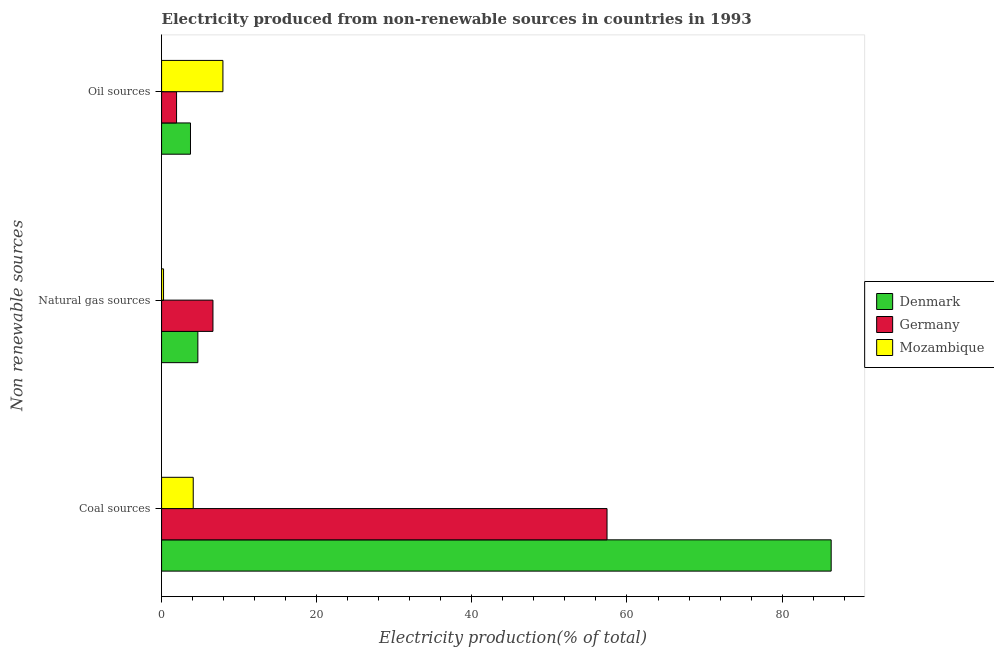How many bars are there on the 3rd tick from the bottom?
Make the answer very short. 3. What is the label of the 2nd group of bars from the top?
Give a very brief answer. Natural gas sources. What is the percentage of electricity produced by natural gas in Germany?
Provide a short and direct response. 6.62. Across all countries, what is the maximum percentage of electricity produced by coal?
Your answer should be compact. 86.32. Across all countries, what is the minimum percentage of electricity produced by coal?
Make the answer very short. 4.08. In which country was the percentage of electricity produced by oil sources maximum?
Your answer should be compact. Mozambique. In which country was the percentage of electricity produced by natural gas minimum?
Offer a terse response. Mozambique. What is the total percentage of electricity produced by natural gas in the graph?
Offer a terse response. 11.55. What is the difference between the percentage of electricity produced by coal in Denmark and that in Germany?
Provide a short and direct response. 28.9. What is the difference between the percentage of electricity produced by natural gas in Germany and the percentage of electricity produced by coal in Mozambique?
Offer a very short reply. 2.54. What is the average percentage of electricity produced by coal per country?
Make the answer very short. 49.28. What is the difference between the percentage of electricity produced by coal and percentage of electricity produced by natural gas in Denmark?
Your answer should be very brief. 81.64. In how many countries, is the percentage of electricity produced by oil sources greater than 72 %?
Your answer should be compact. 0. What is the ratio of the percentage of electricity produced by oil sources in Germany to that in Denmark?
Offer a very short reply. 0.52. Is the difference between the percentage of electricity produced by oil sources in Mozambique and Denmark greater than the difference between the percentage of electricity produced by coal in Mozambique and Denmark?
Ensure brevity in your answer.  Yes. What is the difference between the highest and the second highest percentage of electricity produced by natural gas?
Your response must be concise. 1.95. What is the difference between the highest and the lowest percentage of electricity produced by coal?
Provide a succinct answer. 82.24. In how many countries, is the percentage of electricity produced by natural gas greater than the average percentage of electricity produced by natural gas taken over all countries?
Make the answer very short. 2. Is the sum of the percentage of electricity produced by oil sources in Denmark and Germany greater than the maximum percentage of electricity produced by coal across all countries?
Provide a short and direct response. No. What does the 3rd bar from the top in Oil sources represents?
Your answer should be very brief. Denmark. Is it the case that in every country, the sum of the percentage of electricity produced by coal and percentage of electricity produced by natural gas is greater than the percentage of electricity produced by oil sources?
Your response must be concise. No. How many bars are there?
Your response must be concise. 9. What is the difference between two consecutive major ticks on the X-axis?
Offer a very short reply. 20. Does the graph contain grids?
Offer a terse response. No. How many legend labels are there?
Ensure brevity in your answer.  3. What is the title of the graph?
Provide a succinct answer. Electricity produced from non-renewable sources in countries in 1993. Does "Togo" appear as one of the legend labels in the graph?
Your answer should be compact. No. What is the label or title of the Y-axis?
Your answer should be very brief. Non renewable sources. What is the Electricity production(% of total) of Denmark in Coal sources?
Offer a very short reply. 86.32. What is the Electricity production(% of total) of Germany in Coal sources?
Make the answer very short. 57.43. What is the Electricity production(% of total) in Mozambique in Coal sources?
Offer a very short reply. 4.08. What is the Electricity production(% of total) of Denmark in Natural gas sources?
Your answer should be compact. 4.68. What is the Electricity production(% of total) in Germany in Natural gas sources?
Make the answer very short. 6.62. What is the Electricity production(% of total) in Mozambique in Natural gas sources?
Your response must be concise. 0.26. What is the Electricity production(% of total) of Denmark in Oil sources?
Offer a terse response. 3.73. What is the Electricity production(% of total) of Germany in Oil sources?
Provide a short and direct response. 1.93. What is the Electricity production(% of total) in Mozambique in Oil sources?
Offer a terse response. 7.91. Across all Non renewable sources, what is the maximum Electricity production(% of total) of Denmark?
Offer a terse response. 86.32. Across all Non renewable sources, what is the maximum Electricity production(% of total) of Germany?
Make the answer very short. 57.43. Across all Non renewable sources, what is the maximum Electricity production(% of total) of Mozambique?
Provide a short and direct response. 7.91. Across all Non renewable sources, what is the minimum Electricity production(% of total) in Denmark?
Provide a short and direct response. 3.73. Across all Non renewable sources, what is the minimum Electricity production(% of total) of Germany?
Your answer should be compact. 1.93. Across all Non renewable sources, what is the minimum Electricity production(% of total) in Mozambique?
Your answer should be compact. 0.26. What is the total Electricity production(% of total) in Denmark in the graph?
Your answer should be very brief. 94.73. What is the total Electricity production(% of total) in Germany in the graph?
Ensure brevity in your answer.  65.98. What is the total Electricity production(% of total) of Mozambique in the graph?
Offer a terse response. 12.24. What is the difference between the Electricity production(% of total) of Denmark in Coal sources and that in Natural gas sources?
Provide a short and direct response. 81.64. What is the difference between the Electricity production(% of total) of Germany in Coal sources and that in Natural gas sources?
Keep it short and to the point. 50.8. What is the difference between the Electricity production(% of total) in Mozambique in Coal sources and that in Natural gas sources?
Ensure brevity in your answer.  3.83. What is the difference between the Electricity production(% of total) of Denmark in Coal sources and that in Oil sources?
Keep it short and to the point. 82.6. What is the difference between the Electricity production(% of total) in Germany in Coal sources and that in Oil sources?
Make the answer very short. 55.49. What is the difference between the Electricity production(% of total) of Mozambique in Coal sources and that in Oil sources?
Offer a very short reply. -3.83. What is the difference between the Electricity production(% of total) of Denmark in Natural gas sources and that in Oil sources?
Ensure brevity in your answer.  0.95. What is the difference between the Electricity production(% of total) in Germany in Natural gas sources and that in Oil sources?
Your response must be concise. 4.69. What is the difference between the Electricity production(% of total) of Mozambique in Natural gas sources and that in Oil sources?
Make the answer very short. -7.65. What is the difference between the Electricity production(% of total) of Denmark in Coal sources and the Electricity production(% of total) of Germany in Natural gas sources?
Your answer should be very brief. 79.7. What is the difference between the Electricity production(% of total) in Denmark in Coal sources and the Electricity production(% of total) in Mozambique in Natural gas sources?
Keep it short and to the point. 86.07. What is the difference between the Electricity production(% of total) of Germany in Coal sources and the Electricity production(% of total) of Mozambique in Natural gas sources?
Provide a succinct answer. 57.17. What is the difference between the Electricity production(% of total) in Denmark in Coal sources and the Electricity production(% of total) in Germany in Oil sources?
Make the answer very short. 84.39. What is the difference between the Electricity production(% of total) of Denmark in Coal sources and the Electricity production(% of total) of Mozambique in Oil sources?
Your answer should be compact. 78.41. What is the difference between the Electricity production(% of total) of Germany in Coal sources and the Electricity production(% of total) of Mozambique in Oil sources?
Provide a succinct answer. 49.52. What is the difference between the Electricity production(% of total) in Denmark in Natural gas sources and the Electricity production(% of total) in Germany in Oil sources?
Provide a succinct answer. 2.74. What is the difference between the Electricity production(% of total) in Denmark in Natural gas sources and the Electricity production(% of total) in Mozambique in Oil sources?
Ensure brevity in your answer.  -3.23. What is the difference between the Electricity production(% of total) of Germany in Natural gas sources and the Electricity production(% of total) of Mozambique in Oil sources?
Offer a terse response. -1.29. What is the average Electricity production(% of total) in Denmark per Non renewable sources?
Ensure brevity in your answer.  31.58. What is the average Electricity production(% of total) of Germany per Non renewable sources?
Your answer should be compact. 21.99. What is the average Electricity production(% of total) of Mozambique per Non renewable sources?
Give a very brief answer. 4.08. What is the difference between the Electricity production(% of total) of Denmark and Electricity production(% of total) of Germany in Coal sources?
Your response must be concise. 28.9. What is the difference between the Electricity production(% of total) in Denmark and Electricity production(% of total) in Mozambique in Coal sources?
Offer a very short reply. 82.24. What is the difference between the Electricity production(% of total) in Germany and Electricity production(% of total) in Mozambique in Coal sources?
Offer a very short reply. 53.34. What is the difference between the Electricity production(% of total) of Denmark and Electricity production(% of total) of Germany in Natural gas sources?
Your answer should be compact. -1.95. What is the difference between the Electricity production(% of total) in Denmark and Electricity production(% of total) in Mozambique in Natural gas sources?
Give a very brief answer. 4.42. What is the difference between the Electricity production(% of total) of Germany and Electricity production(% of total) of Mozambique in Natural gas sources?
Provide a short and direct response. 6.37. What is the difference between the Electricity production(% of total) of Denmark and Electricity production(% of total) of Germany in Oil sources?
Keep it short and to the point. 1.79. What is the difference between the Electricity production(% of total) in Denmark and Electricity production(% of total) in Mozambique in Oil sources?
Offer a very short reply. -4.18. What is the difference between the Electricity production(% of total) in Germany and Electricity production(% of total) in Mozambique in Oil sources?
Make the answer very short. -5.98. What is the ratio of the Electricity production(% of total) in Denmark in Coal sources to that in Natural gas sources?
Offer a very short reply. 18.46. What is the ratio of the Electricity production(% of total) of Germany in Coal sources to that in Natural gas sources?
Offer a very short reply. 8.67. What is the ratio of the Electricity production(% of total) of Denmark in Coal sources to that in Oil sources?
Offer a terse response. 23.17. What is the ratio of the Electricity production(% of total) in Germany in Coal sources to that in Oil sources?
Keep it short and to the point. 29.71. What is the ratio of the Electricity production(% of total) of Mozambique in Coal sources to that in Oil sources?
Ensure brevity in your answer.  0.52. What is the ratio of the Electricity production(% of total) of Denmark in Natural gas sources to that in Oil sources?
Your response must be concise. 1.26. What is the ratio of the Electricity production(% of total) in Germany in Natural gas sources to that in Oil sources?
Offer a very short reply. 3.43. What is the ratio of the Electricity production(% of total) of Mozambique in Natural gas sources to that in Oil sources?
Ensure brevity in your answer.  0.03. What is the difference between the highest and the second highest Electricity production(% of total) of Denmark?
Keep it short and to the point. 81.64. What is the difference between the highest and the second highest Electricity production(% of total) in Germany?
Offer a terse response. 50.8. What is the difference between the highest and the second highest Electricity production(% of total) of Mozambique?
Your answer should be very brief. 3.83. What is the difference between the highest and the lowest Electricity production(% of total) of Denmark?
Offer a very short reply. 82.6. What is the difference between the highest and the lowest Electricity production(% of total) of Germany?
Offer a very short reply. 55.49. What is the difference between the highest and the lowest Electricity production(% of total) of Mozambique?
Ensure brevity in your answer.  7.65. 